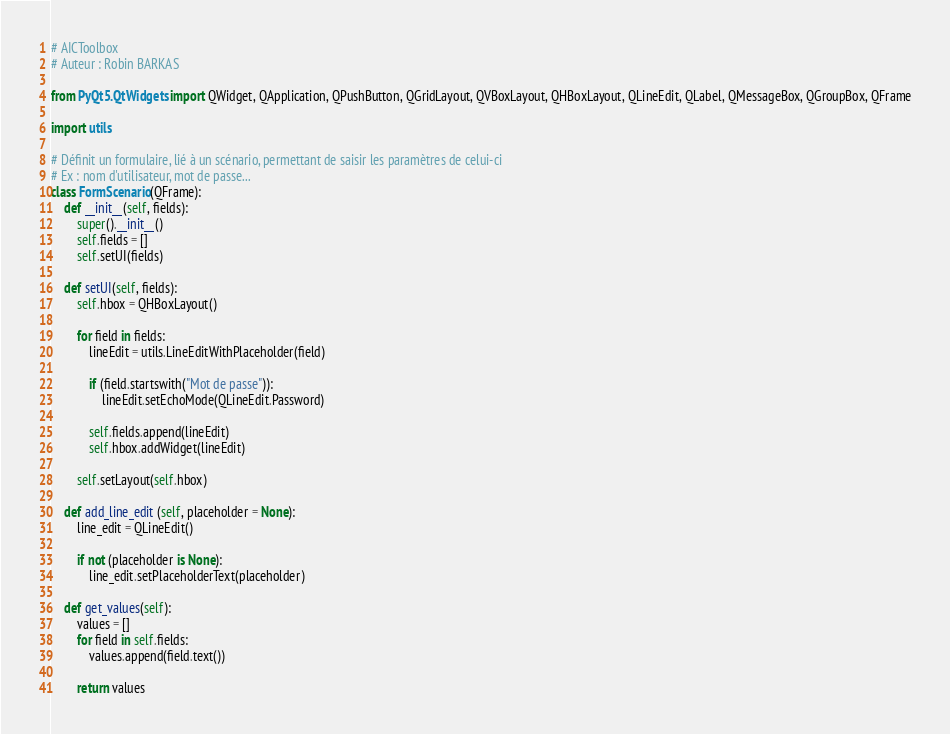Convert code to text. <code><loc_0><loc_0><loc_500><loc_500><_Python_># AICToolbox
# Auteur : Robin BARKAS

from PyQt5.QtWidgets import QWidget, QApplication, QPushButton, QGridLayout, QVBoxLayout, QHBoxLayout, QLineEdit, QLabel, QMessageBox, QGroupBox, QFrame

import utils

# Définit un formulaire, lié à un scénario, permettant de saisir les paramètres de celui-ci
# Ex : nom d'utilisateur, mot de passe...
class FormScenario(QFrame):
    def __init__(self, fields):
        super().__init__()
        self.fields = []
        self.setUI(fields)

    def setUI(self, fields):
        self.hbox = QHBoxLayout()

        for field in fields:
            lineEdit = utils.LineEditWithPlaceholder(field)

            if (field.startswith("Mot de passe")):
                lineEdit.setEchoMode(QLineEdit.Password)

            self.fields.append(lineEdit)
            self.hbox.addWidget(lineEdit)

        self.setLayout(self.hbox)

    def add_line_edit (self, placeholder = None):
        line_edit = QLineEdit()

        if not (placeholder is None):
            line_edit.setPlaceholderText(placeholder)

    def get_values(self):
        values = []
        for field in self.fields:
            values.append(field.text())

        return values
</code> 